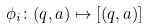<formula> <loc_0><loc_0><loc_500><loc_500>\phi _ { i } \colon ( q , a ) \mapsto [ ( q , a ) ]</formula> 